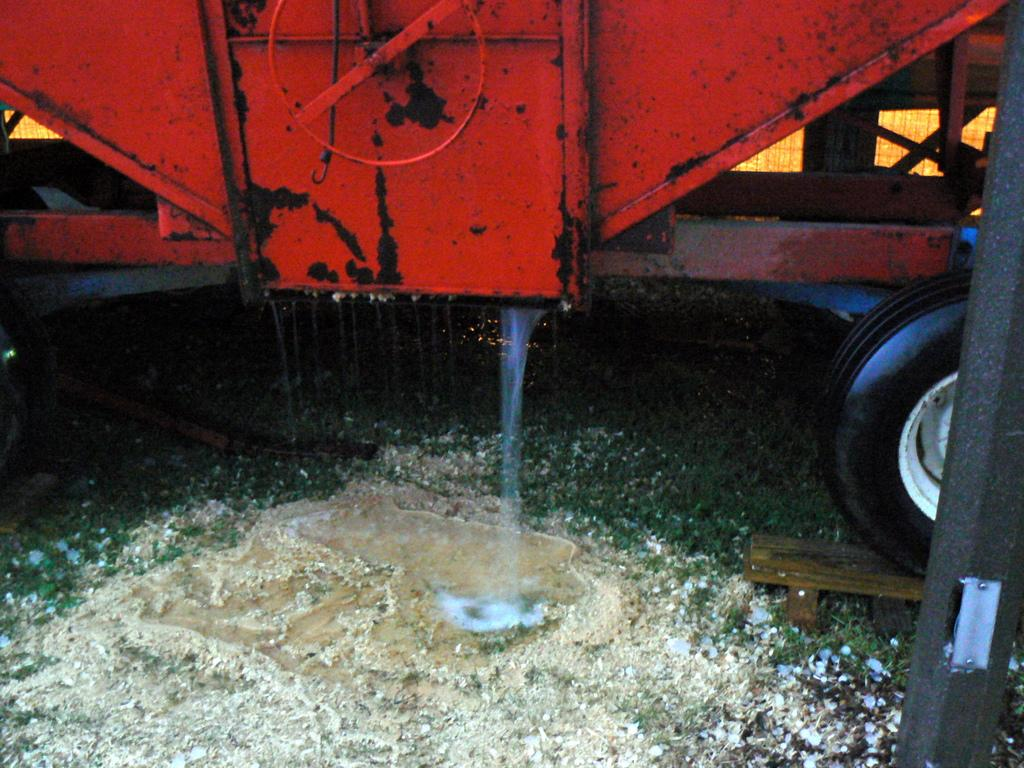What is coming out of the vehicle in the image? Water is flowing from a vehicle in the image. Where is the water located in relation to the land? The water is on the land. What can be seen on the right side of the image? There is a black color pole and a wooden object on the right side of the image. What type of meat is being ploughed into the ground in the image? There is no meat or plough present in the image. 